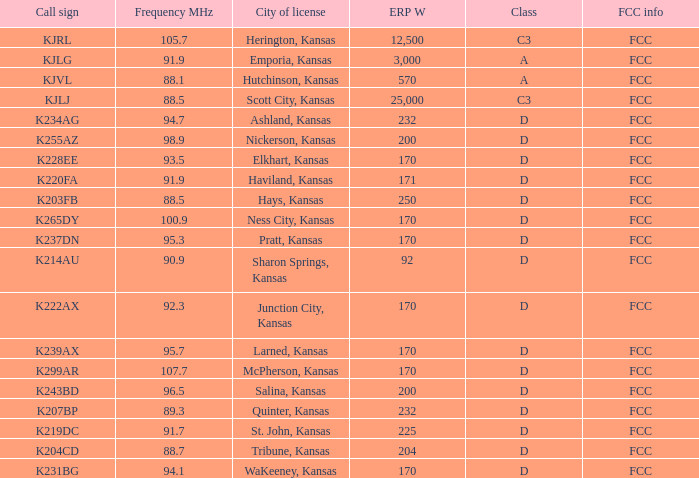Call sign of k231bg has what sum of erp w? 170.0. 